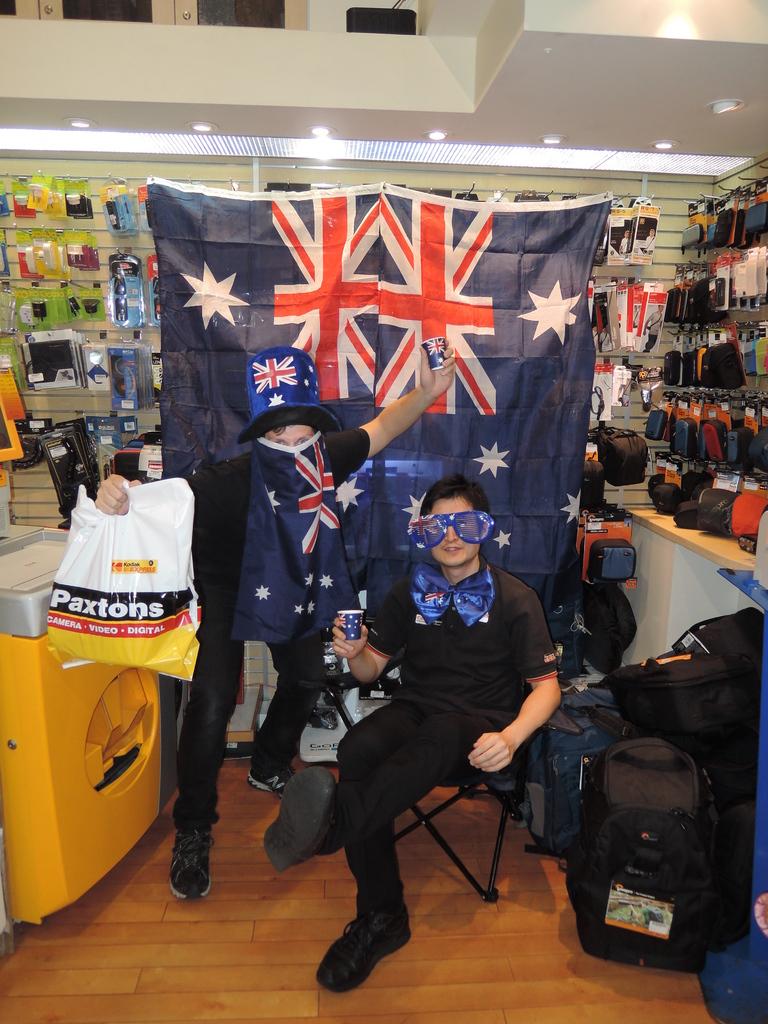Store name on this bag?
Your answer should be compact. Paxtons. 